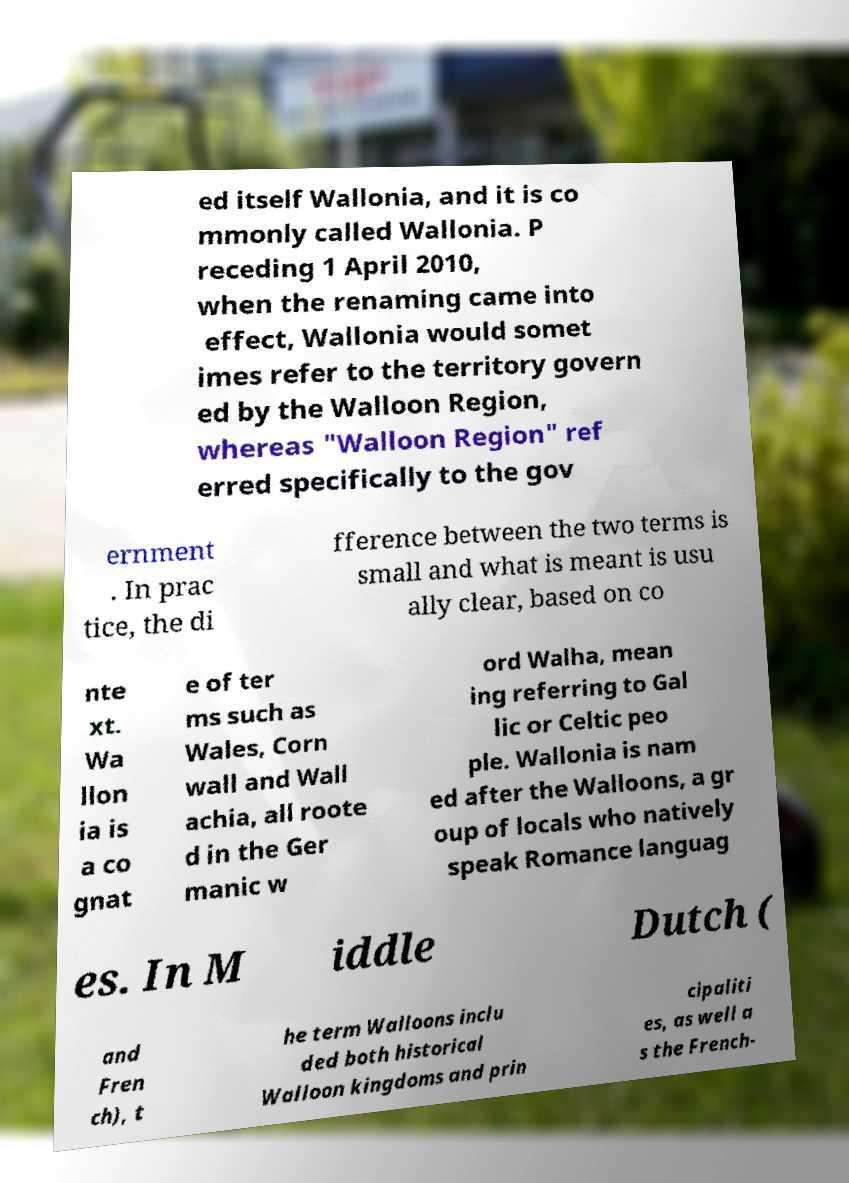Please identify and transcribe the text found in this image. ed itself Wallonia, and it is co mmonly called Wallonia. P receding 1 April 2010, when the renaming came into effect, Wallonia would somet imes refer to the territory govern ed by the Walloon Region, whereas "Walloon Region" ref erred specifically to the gov ernment . In prac tice, the di fference between the two terms is small and what is meant is usu ally clear, based on co nte xt. Wa llon ia is a co gnat e of ter ms such as Wales, Corn wall and Wall achia, all roote d in the Ger manic w ord Walha, mean ing referring to Gal lic or Celtic peo ple. Wallonia is nam ed after the Walloons, a gr oup of locals who natively speak Romance languag es. In M iddle Dutch ( and Fren ch), t he term Walloons inclu ded both historical Walloon kingdoms and prin cipaliti es, as well a s the French- 